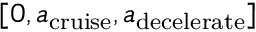<formula> <loc_0><loc_0><loc_500><loc_500>[ 0 , { a _ { c r u i s e } } , { a _ { d e c e l e r a t e } } ]</formula> 